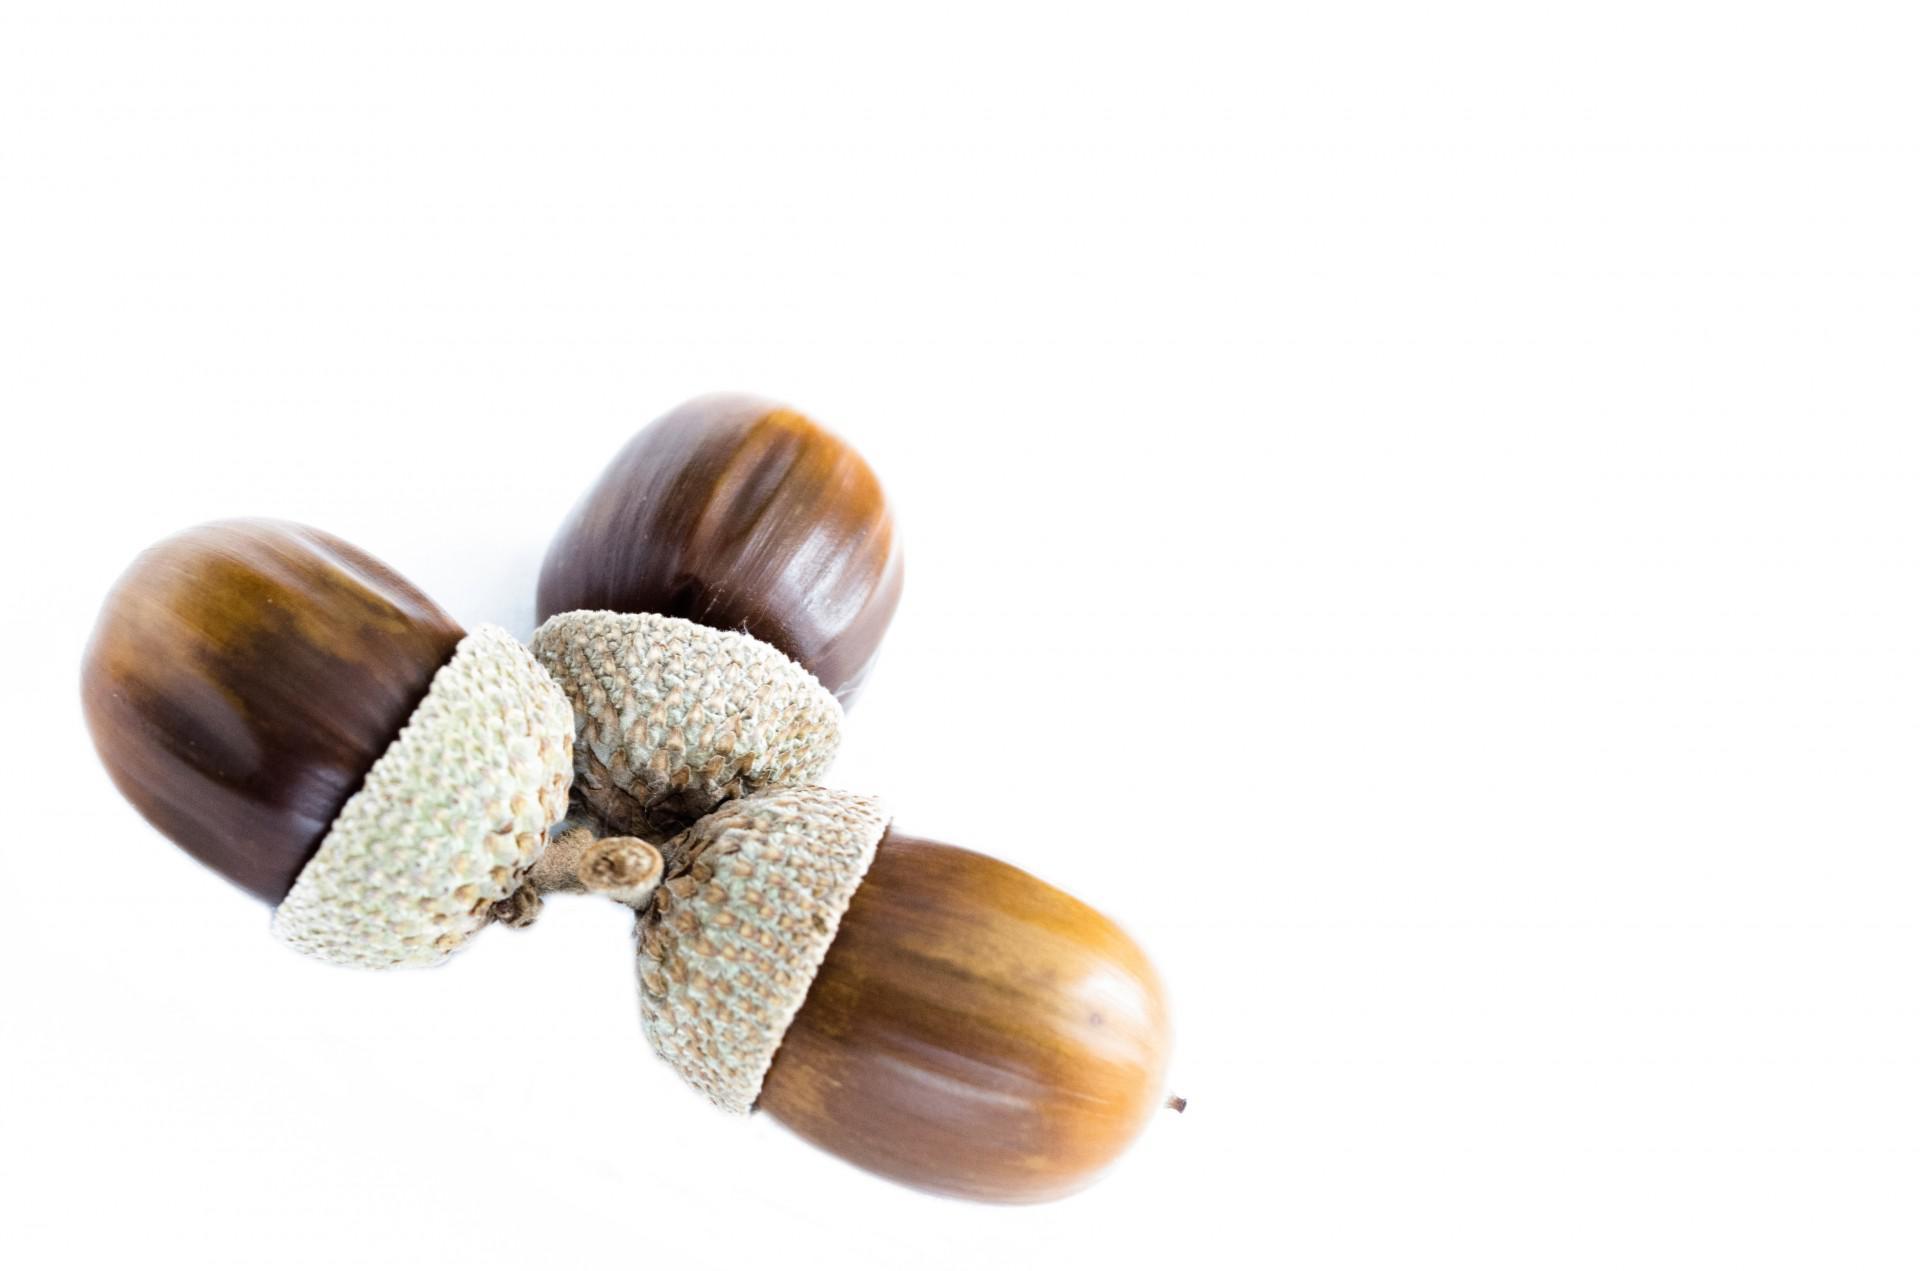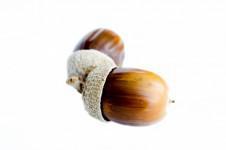The first image is the image on the left, the second image is the image on the right. Evaluate the accuracy of this statement regarding the images: "There are four acorns in total.". Is it true? Answer yes or no. No. 